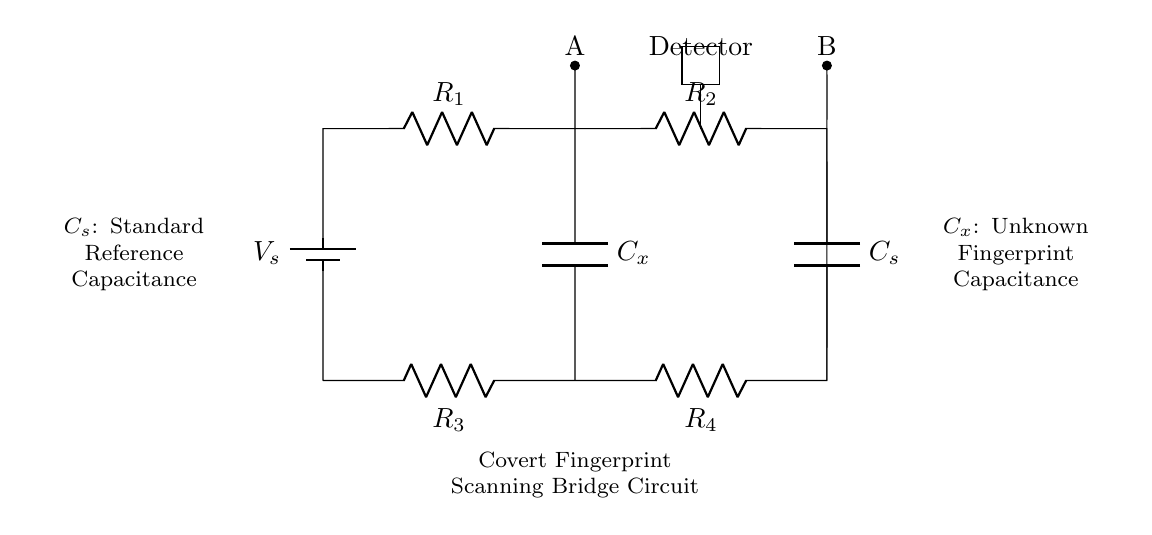What is the type of this circuit? This circuit is a capacitance bridge, which is typically used for measuring unknown capacitances by balancing them against known values. The presence of capacitors and resistors arranged in a bridge configuration confirms this.
Answer: capacitance bridge What are the values of the resistors shown? The resistor values are not specified here, but they are labeled as R1, R2, R3, and R4. Typically, these resistors would be set to specific values to establish the balance required for the measurements.
Answer: R1, R2, R3, R4 What does Cx represent in the circuit? Cx is labeled as the unknown fingerprint capacitance, which is the main quantity that the bridge is designed to measure. This indicates that the circuit is set up to detect the capacitance associated with a fingerprint.
Answer: unknown fingerprint capacitance How many capacitors are present in the circuit? There are two capacitors present in the circuit: Cx (unknown capacitance) and Cs (standard reference capacitance). The construction of the bridge requires both to compare and measure the unknown capacitance accurately.
Answer: two What is the purpose of the detector in this circuit? The detector's purpose is to sense the balance condition of the bridge. When the bridge is balanced, it indicates that the capacitance being measured (Cx) is equal to the reference capacitance (Cs), which can then be inferred from the circuit's behavior.
Answer: sense balance condition What occurs if Cx equals Cs? If Cx equals Cs, the bridge circuit reaches a balance point, which typically results in zero voltage at the detector. This indicates a successful measurement of the unknown capacitance, confirming it matches the reference capacitance.
Answer: zero voltage 